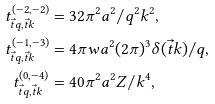Convert formula to latex. <formula><loc_0><loc_0><loc_500><loc_500>t ^ { ( - 2 , - 2 ) } _ { \vec { t } q , \vec { t } k } & = 3 2 \pi ^ { 2 } a ^ { 2 } / q ^ { 2 } k ^ { 2 } , \\ t ^ { ( - 1 , - 3 ) } _ { \vec { t } q , \vec { t } k } & = 4 \pi w a ^ { 2 } ( 2 \pi ) ^ { 3 } \delta ( \vec { t } k ) / q , \\ t ^ { ( 0 , - 4 ) } _ { \vec { t } q , \vec { t } k } & = 4 0 \pi ^ { 2 } a ^ { 2 } Z / k ^ { 4 } ,</formula> 